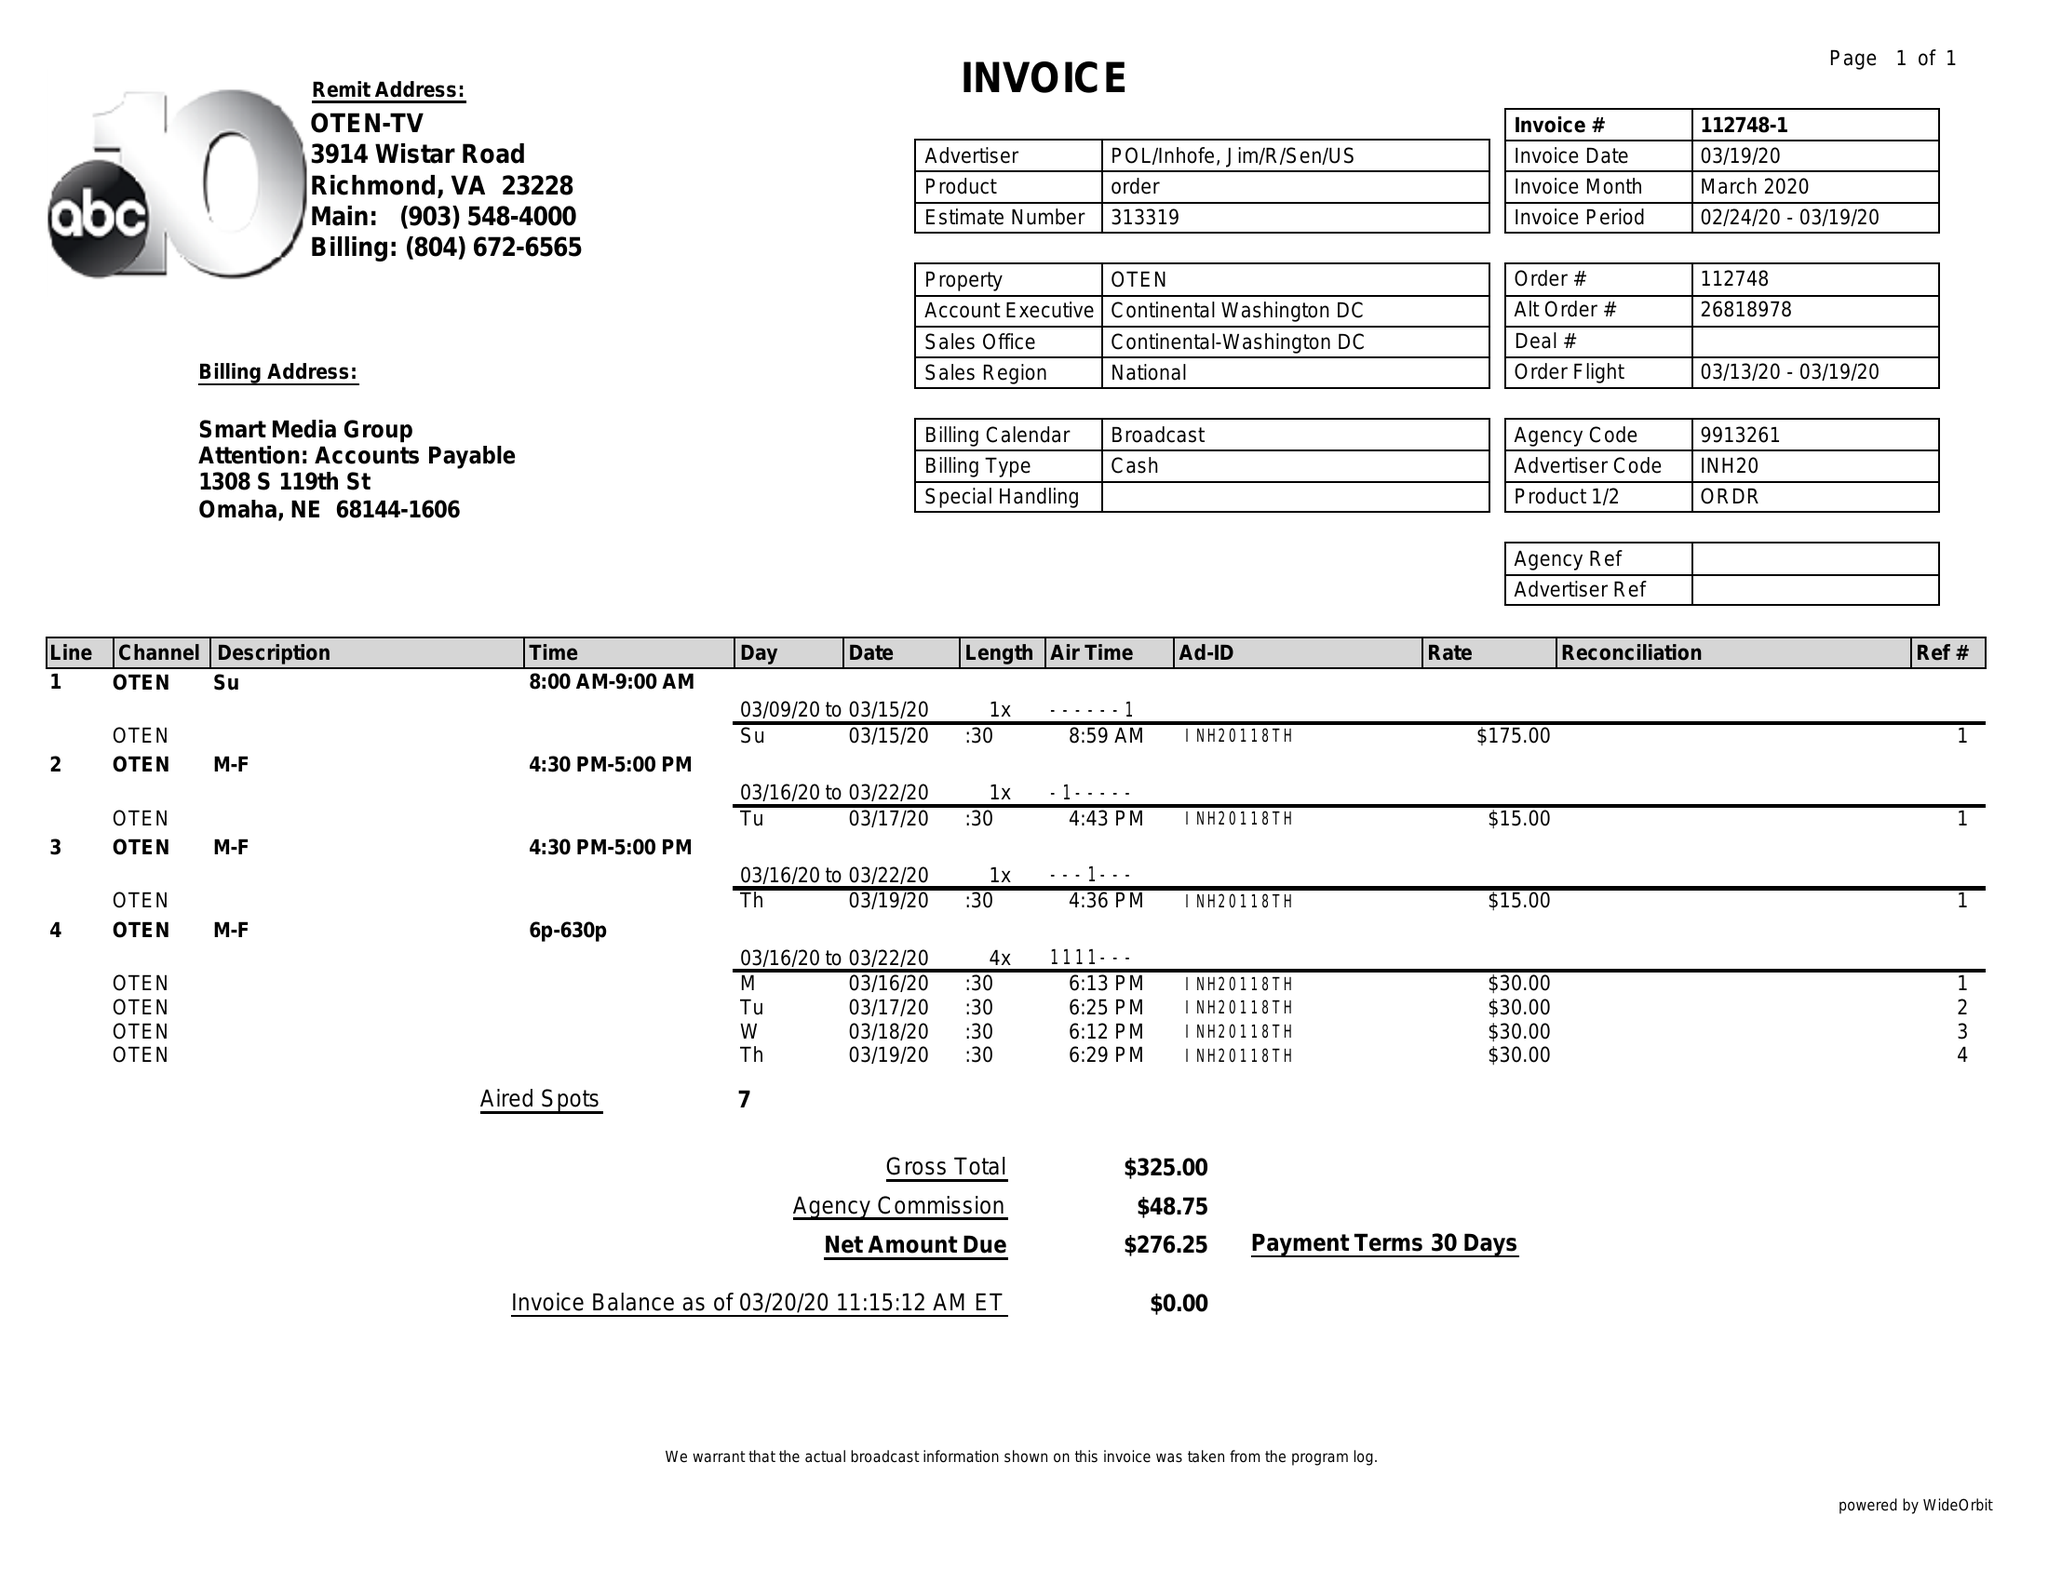What is the value for the flight_from?
Answer the question using a single word or phrase. 03/13/20 